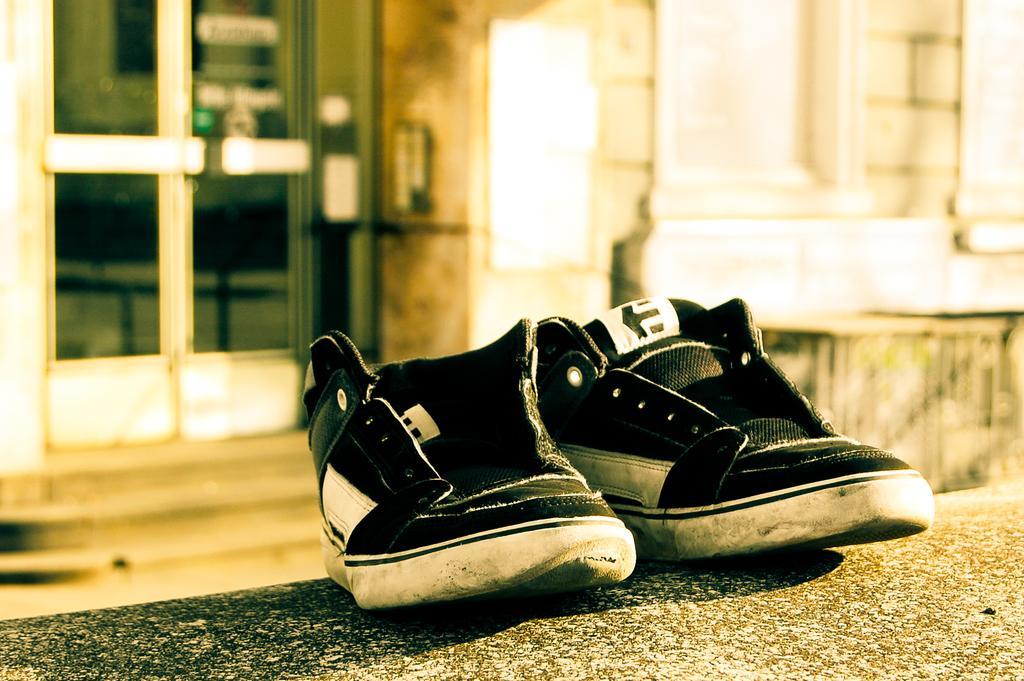Describe this image in one or two sentences. There are shoes in black color in the middle of an image. On the left side there are glass doors and this is the wall in this image. 